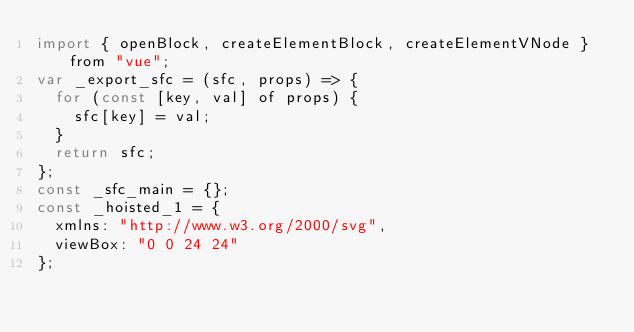Convert code to text. <code><loc_0><loc_0><loc_500><loc_500><_JavaScript_>import { openBlock, createElementBlock, createElementVNode } from "vue";
var _export_sfc = (sfc, props) => {
  for (const [key, val] of props) {
    sfc[key] = val;
  }
  return sfc;
};
const _sfc_main = {};
const _hoisted_1 = {
  xmlns: "http://www.w3.org/2000/svg",
  viewBox: "0 0 24 24"
};</code> 